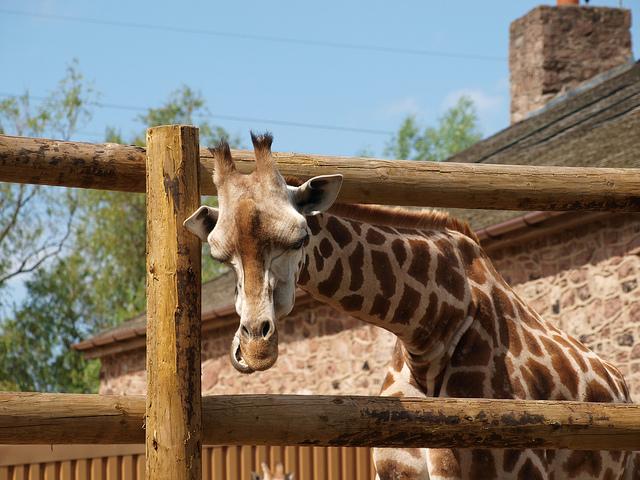Is this giraffe behind a fence?
Concise answer only. Yes. Is this giraffe disabled?
Give a very brief answer. No. Is the animal trying to escape?
Be succinct. No. 